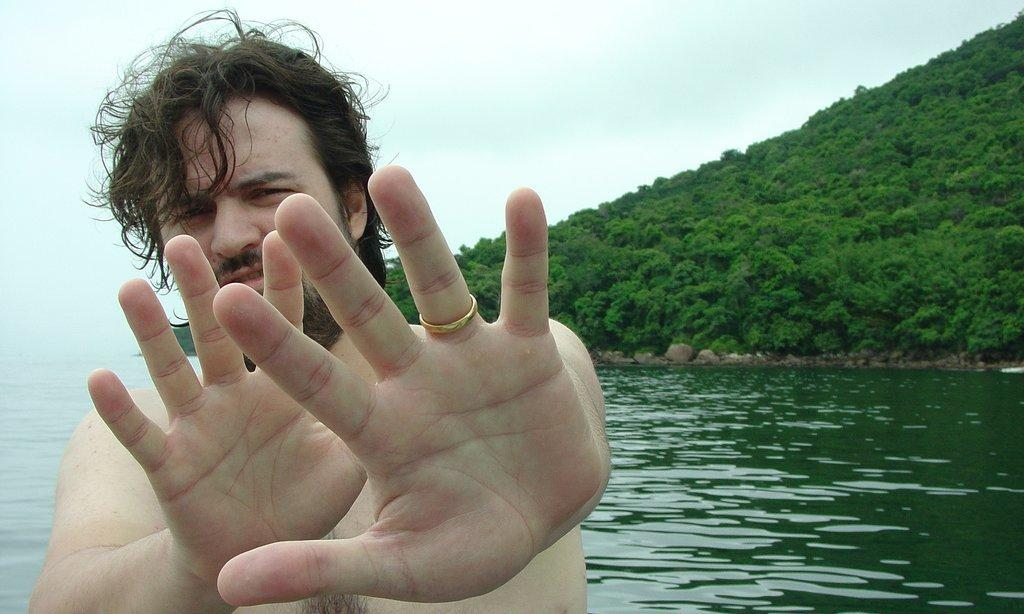What can be seen at the top of the image? The sky is visible towards the top of the image. What is located towards the right of the image? There are trees towards the right of the image. What is present in the image besides the sky and trees? There is water in the image. Can you describe the person in the image? There is a man standing in the image. How many visitors are present in the image? There is no mention of visitors in the image; only a man is present. What type of wall can be seen surrounding the water in the image? There is no wall present in the image; it features a man standing near water with trees and sky in the background. 